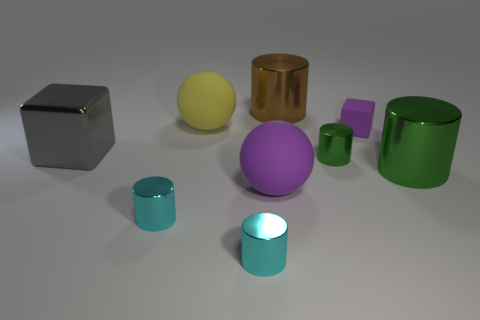Subtract 1 cylinders. How many cylinders are left? 4 Subtract all brown cylinders. How many cylinders are left? 4 Subtract all large brown metal cylinders. How many cylinders are left? 4 Subtract all yellow cylinders. Subtract all gray spheres. How many cylinders are left? 5 Add 1 large rubber balls. How many objects exist? 10 Subtract all blocks. How many objects are left? 7 Subtract 0 blue balls. How many objects are left? 9 Subtract all purple blocks. Subtract all small purple metal objects. How many objects are left? 8 Add 1 small cylinders. How many small cylinders are left? 4 Add 9 small yellow matte blocks. How many small yellow matte blocks exist? 9 